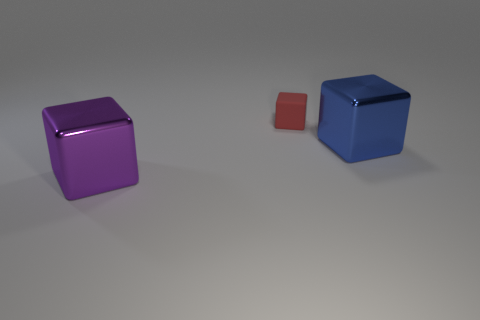Assuming these cubes have different textures, can you describe what they might feel like? If the cubes have diverse textures, the red one might feel smooth and slightly warm due to its smaller size, which could allow it to heat up quickly. The purple and blue cubes, if made of a matte material, might feel cooler and have a slight grip to the touch due to a less reflective surface. 